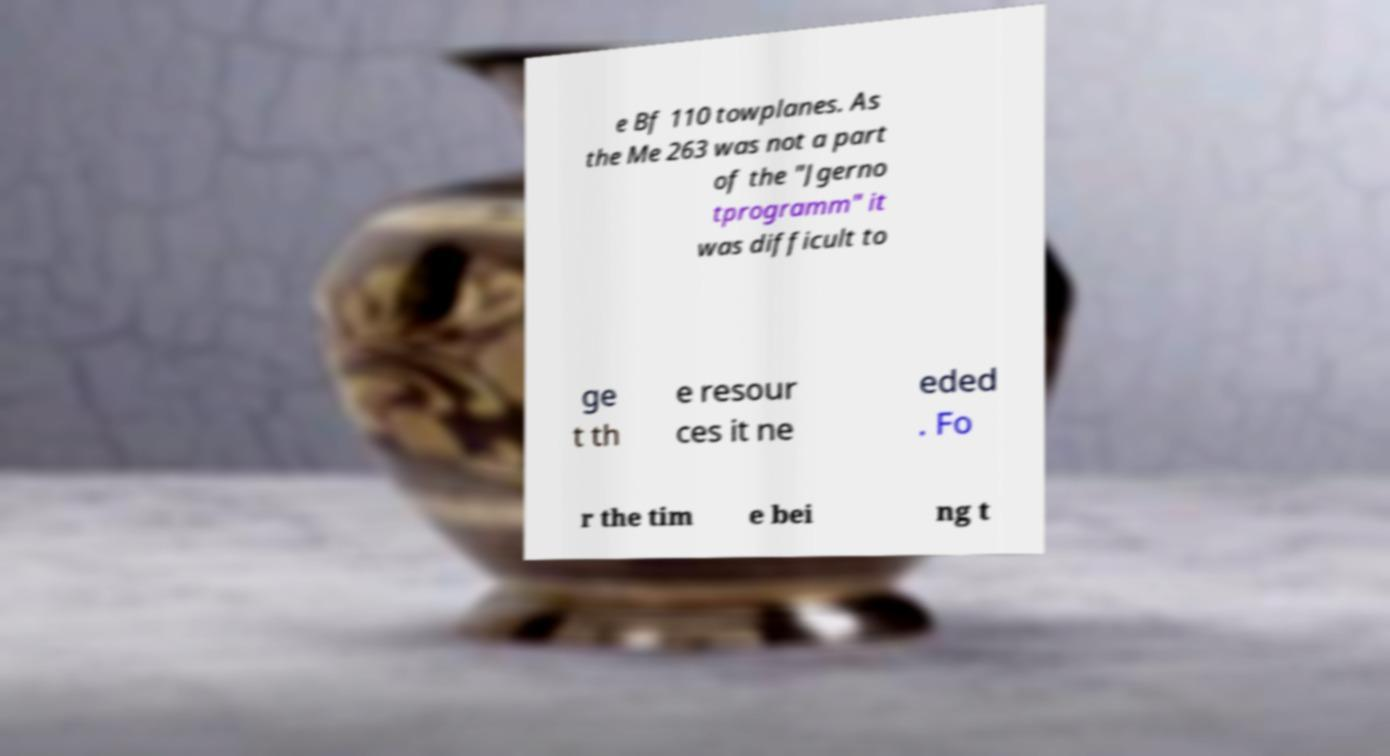Can you read and provide the text displayed in the image?This photo seems to have some interesting text. Can you extract and type it out for me? e Bf 110 towplanes. As the Me 263 was not a part of the "Jgerno tprogramm" it was difficult to ge t th e resour ces it ne eded . Fo r the tim e bei ng t 